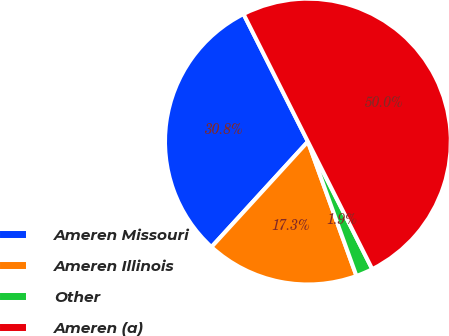<chart> <loc_0><loc_0><loc_500><loc_500><pie_chart><fcel>Ameren Missouri<fcel>Ameren Illinois<fcel>Other<fcel>Ameren (a)<nl><fcel>30.77%<fcel>17.31%<fcel>1.92%<fcel>50.0%<nl></chart> 